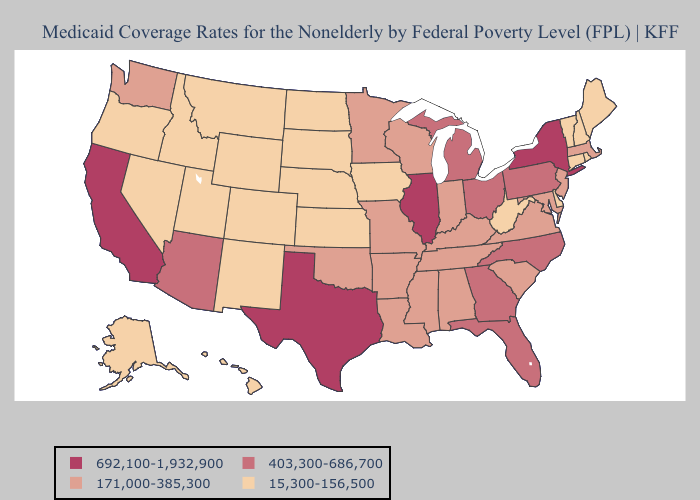Does the first symbol in the legend represent the smallest category?
Short answer required. No. Does Montana have the same value as North Carolina?
Quick response, please. No. What is the highest value in the Northeast ?
Write a very short answer. 692,100-1,932,900. Name the states that have a value in the range 692,100-1,932,900?
Short answer required. California, Illinois, New York, Texas. Does Nevada have the lowest value in the USA?
Quick response, please. Yes. What is the value of Maine?
Concise answer only. 15,300-156,500. Among the states that border Missouri , which have the highest value?
Write a very short answer. Illinois. Name the states that have a value in the range 692,100-1,932,900?
Short answer required. California, Illinois, New York, Texas. What is the highest value in states that border Illinois?
Write a very short answer. 171,000-385,300. Does Wisconsin have the lowest value in the MidWest?
Write a very short answer. No. Name the states that have a value in the range 692,100-1,932,900?
Give a very brief answer. California, Illinois, New York, Texas. Does the first symbol in the legend represent the smallest category?
Concise answer only. No. Which states have the lowest value in the MidWest?
Answer briefly. Iowa, Kansas, Nebraska, North Dakota, South Dakota. Does Illinois have the highest value in the MidWest?
Answer briefly. Yes. What is the lowest value in the USA?
Short answer required. 15,300-156,500. 